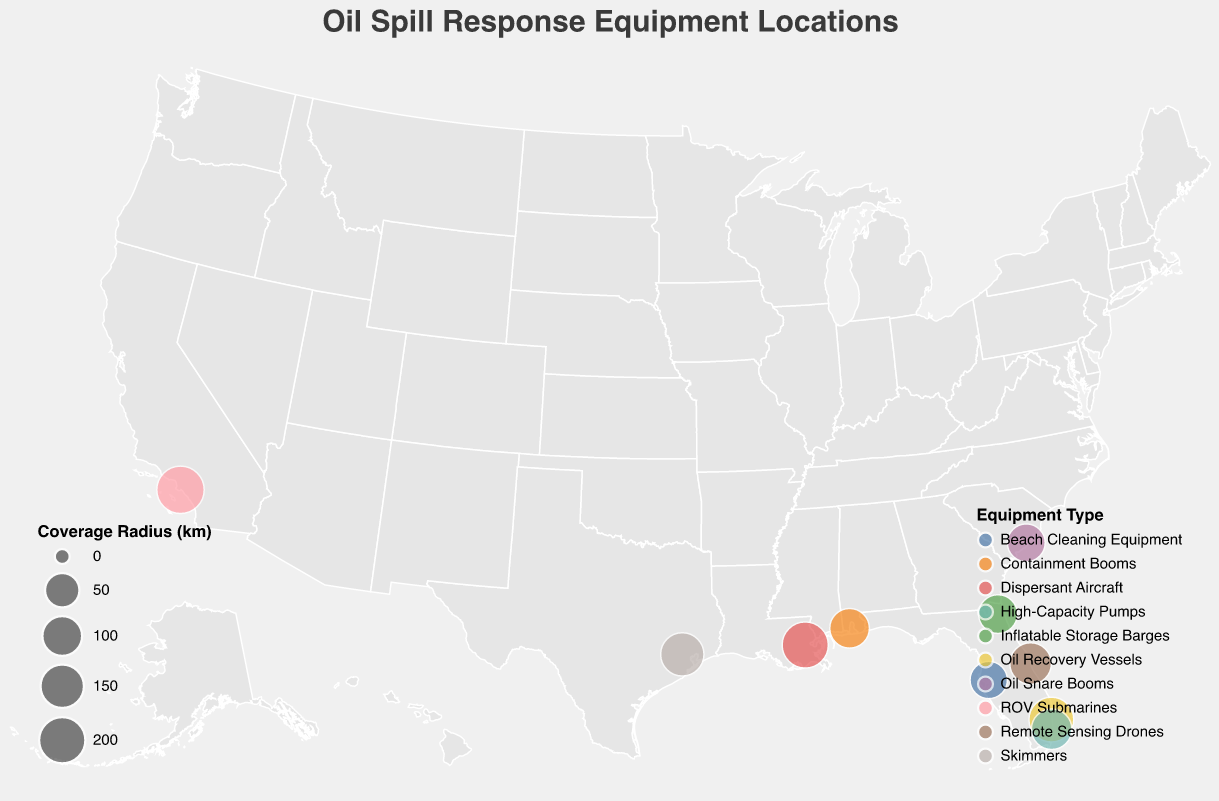What is the title of the plot? The title of the plot is displayed at the top center of the figure and reads "Oil Spill Response Equipment Locations".
Answer: Oil Spill Response Equipment Locations How many different types of oil spill response equipment are represented in the plot? To determine this, check the legend, which lists the unique equipment types by color.
Answer: 10 Which equipment type is associated with the Houston Response Center, and what is its coverage radius? By hovering over or checking the tooltip for the Houston Response Center, we see that it has "Skimmers" with a coverage radius of 150 km.
Answer: Skimmers, 150 km Which location has the largest coverage radius, and what type of equipment does it have? By examining the sizes of the circles, the largest one is seen in Long Beach Facility, which has ROV Submarines with a coverage radius of 225 km.
Answer: Long Beach Facility, ROV Submarines Which equipment type is closest to the Mars Platform? By checking the tooltips or cross-referencing the data, New Orleans Depot is closest to Mars Platform, and it has Dispersant Aircraft.
Answer: Dispersant Aircraft Compare the coverage radius of the equipment at Fort Lauderdale Hub and Miami Response Unit. Which one has a larger coverage radius and by how much? Fort Lauderdale Hub has a coverage radius of 175 km, while Miami Response Unit has 110 km. The difference in coverage radius is 175 - 110 = 65 km.
Answer: Fort Lauderdale Hub by 65 km What is the average coverage radius of the oil spill response equipment locations? Sum the coverage radii of all locations: (150 + 100 + 200 + 175 + 75 + 125 + 90 + 110 + 80 + 225) = 1330 km, then divide by the number of locations (10), resulting in 1330 / 10 = 133 km.
Answer: 133 km How many oil spill response locations are in Florida? By looking at the geographic locations on the map, there are three in Florida: Fort Lauderdale Hub, Tampa Bay Station, and Miami Response Unit.
Answer: 3 Which location in South Carolina has oil spill response equipment, and what equipment type is it? Check the map and the tooltip for the South Carolina location, which shows Charleston Base with Oil Snare Booms.
Answer: Charleston Base, Oil Snare Booms What states have more than one oil spill response location? By examining the geographic distribution on the map, the state of Florida (Fort Lauderdale, Tampa Bay, Miami) has more than one response location.
Answer: Florida 